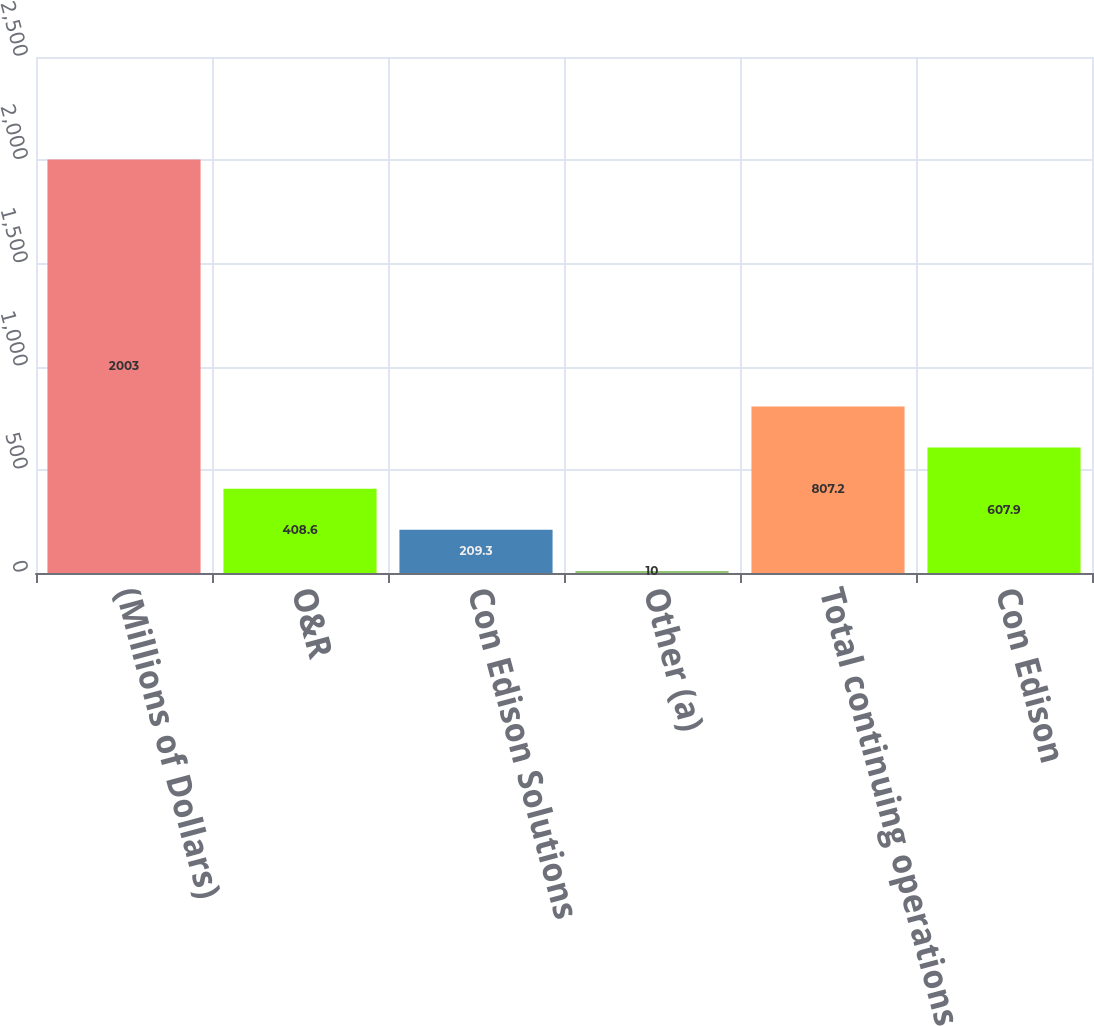Convert chart. <chart><loc_0><loc_0><loc_500><loc_500><bar_chart><fcel>(Millions of Dollars)<fcel>O&R<fcel>Con Edison Solutions<fcel>Other (a)<fcel>Total continuing operations<fcel>Con Edison<nl><fcel>2003<fcel>408.6<fcel>209.3<fcel>10<fcel>807.2<fcel>607.9<nl></chart> 